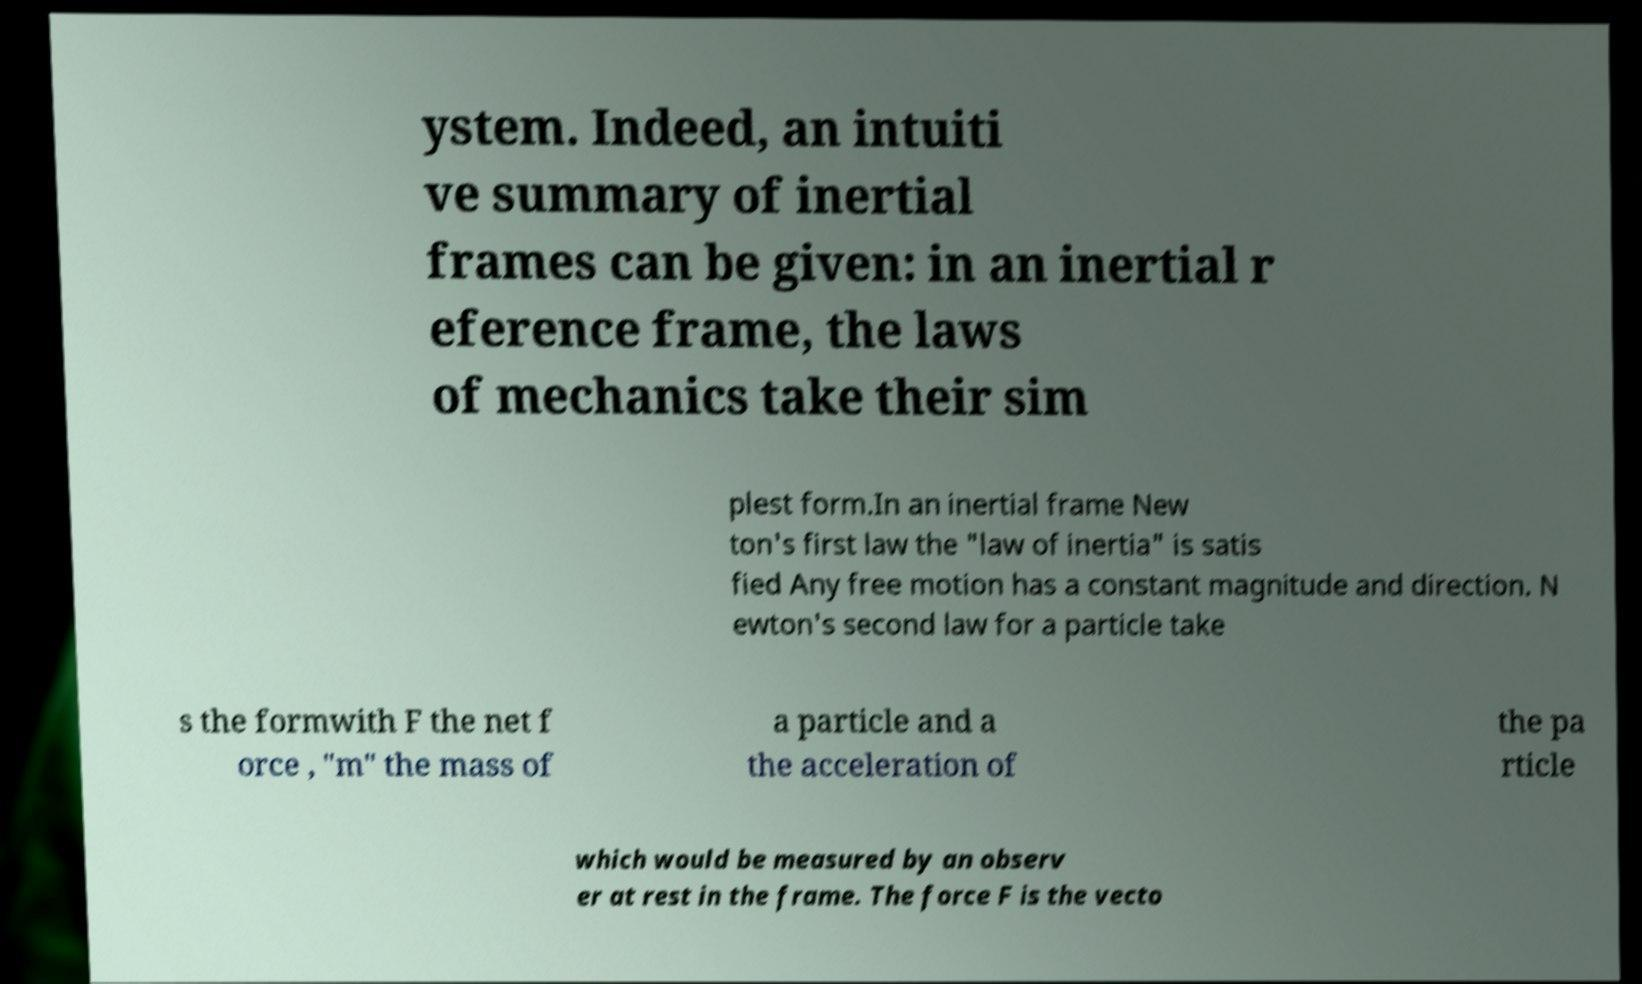Can you read and provide the text displayed in the image?This photo seems to have some interesting text. Can you extract and type it out for me? ystem. Indeed, an intuiti ve summary of inertial frames can be given: in an inertial r eference frame, the laws of mechanics take their sim plest form.In an inertial frame New ton's first law the "law of inertia" is satis fied Any free motion has a constant magnitude and direction. N ewton's second law for a particle take s the formwith F the net f orce , "m" the mass of a particle and a the acceleration of the pa rticle which would be measured by an observ er at rest in the frame. The force F is the vecto 